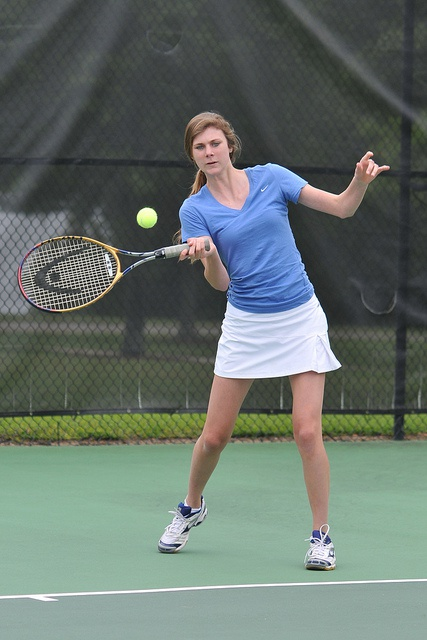Describe the objects in this image and their specific colors. I can see people in gray, lavender, and lightpink tones, tennis racket in gray, black, darkgray, and lightgray tones, and sports ball in gray, khaki, lightyellow, and lightgreen tones in this image. 